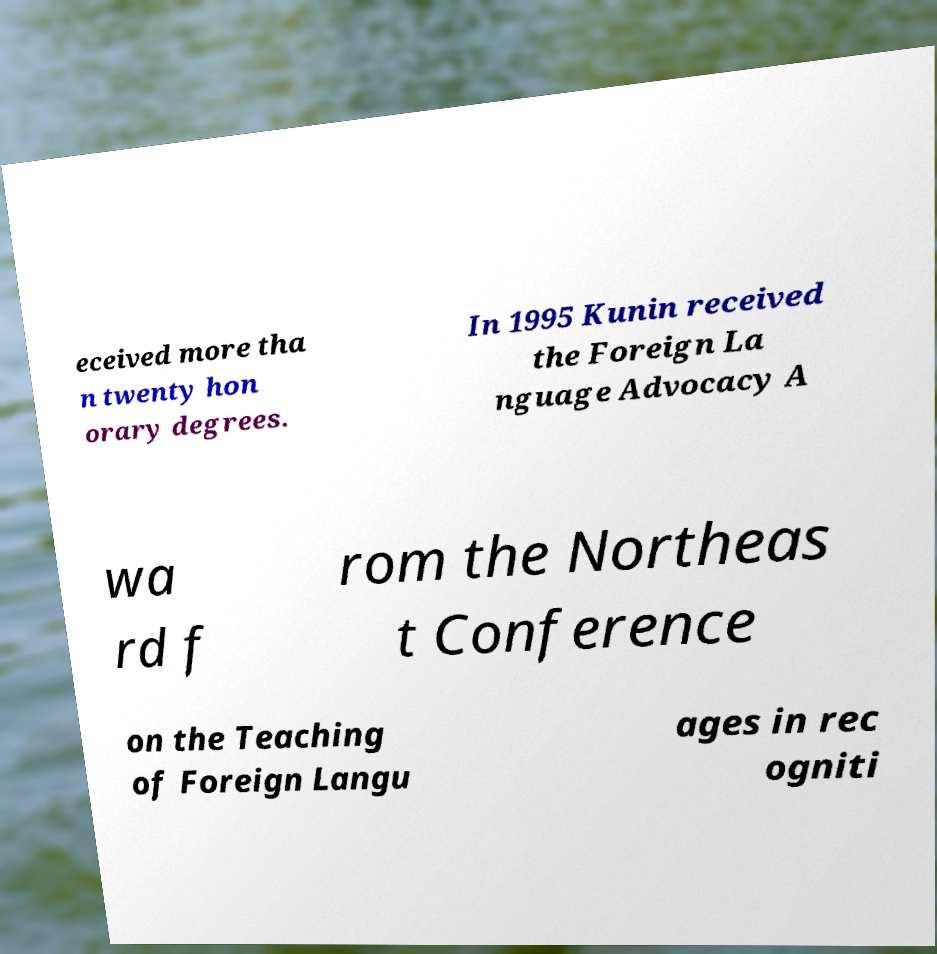Can you read and provide the text displayed in the image?This photo seems to have some interesting text. Can you extract and type it out for me? eceived more tha n twenty hon orary degrees. In 1995 Kunin received the Foreign La nguage Advocacy A wa rd f rom the Northeas t Conference on the Teaching of Foreign Langu ages in rec ogniti 